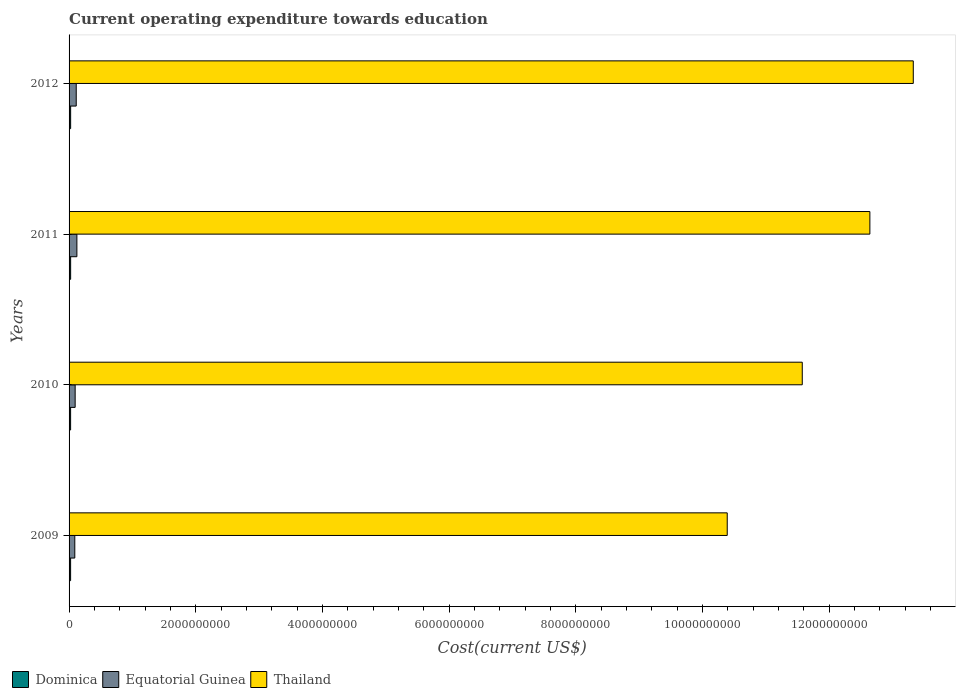How many groups of bars are there?
Your response must be concise. 4. Are the number of bars per tick equal to the number of legend labels?
Provide a short and direct response. Yes. Are the number of bars on each tick of the Y-axis equal?
Provide a succinct answer. Yes. How many bars are there on the 2nd tick from the bottom?
Your response must be concise. 3. What is the label of the 3rd group of bars from the top?
Provide a succinct answer. 2010. What is the expenditure towards education in Dominica in 2009?
Offer a very short reply. 2.43e+07. Across all years, what is the maximum expenditure towards education in Thailand?
Offer a very short reply. 1.33e+1. Across all years, what is the minimum expenditure towards education in Dominica?
Provide a short and direct response. 2.42e+07. What is the total expenditure towards education in Thailand in the graph?
Provide a short and direct response. 4.79e+1. What is the difference between the expenditure towards education in Equatorial Guinea in 2010 and that in 2012?
Provide a short and direct response. -1.69e+07. What is the difference between the expenditure towards education in Equatorial Guinea in 2009 and the expenditure towards education in Dominica in 2012?
Offer a very short reply. 6.57e+07. What is the average expenditure towards education in Thailand per year?
Give a very brief answer. 1.20e+1. In the year 2011, what is the difference between the expenditure towards education in Dominica and expenditure towards education in Equatorial Guinea?
Keep it short and to the point. -9.86e+07. In how many years, is the expenditure towards education in Dominica greater than 6800000000 US$?
Keep it short and to the point. 0. What is the ratio of the expenditure towards education in Thailand in 2011 to that in 2012?
Make the answer very short. 0.95. What is the difference between the highest and the second highest expenditure towards education in Dominica?
Offer a very short reply. 7.35e+04. What is the difference between the highest and the lowest expenditure towards education in Thailand?
Your response must be concise. 2.94e+09. Is the sum of the expenditure towards education in Equatorial Guinea in 2009 and 2011 greater than the maximum expenditure towards education in Dominica across all years?
Offer a very short reply. Yes. What does the 2nd bar from the top in 2011 represents?
Keep it short and to the point. Equatorial Guinea. What does the 1st bar from the bottom in 2010 represents?
Provide a succinct answer. Dominica. Is it the case that in every year, the sum of the expenditure towards education in Dominica and expenditure towards education in Equatorial Guinea is greater than the expenditure towards education in Thailand?
Your response must be concise. No. How many bars are there?
Provide a succinct answer. 12. Are all the bars in the graph horizontal?
Your response must be concise. Yes. Does the graph contain any zero values?
Provide a succinct answer. No. How many legend labels are there?
Give a very brief answer. 3. What is the title of the graph?
Your answer should be very brief. Current operating expenditure towards education. What is the label or title of the X-axis?
Provide a succinct answer. Cost(current US$). What is the label or title of the Y-axis?
Ensure brevity in your answer.  Years. What is the Cost(current US$) in Dominica in 2009?
Keep it short and to the point. 2.43e+07. What is the Cost(current US$) in Equatorial Guinea in 2009?
Provide a succinct answer. 9.05e+07. What is the Cost(current US$) of Thailand in 2009?
Offer a very short reply. 1.04e+1. What is the Cost(current US$) of Dominica in 2010?
Give a very brief answer. 2.42e+07. What is the Cost(current US$) in Equatorial Guinea in 2010?
Give a very brief answer. 9.61e+07. What is the Cost(current US$) of Thailand in 2010?
Provide a succinct answer. 1.16e+1. What is the Cost(current US$) in Dominica in 2011?
Provide a short and direct response. 2.49e+07. What is the Cost(current US$) in Equatorial Guinea in 2011?
Your response must be concise. 1.23e+08. What is the Cost(current US$) of Thailand in 2011?
Provide a short and direct response. 1.26e+1. What is the Cost(current US$) in Dominica in 2012?
Your answer should be compact. 2.48e+07. What is the Cost(current US$) of Equatorial Guinea in 2012?
Offer a terse response. 1.13e+08. What is the Cost(current US$) of Thailand in 2012?
Ensure brevity in your answer.  1.33e+1. Across all years, what is the maximum Cost(current US$) of Dominica?
Your answer should be compact. 2.49e+07. Across all years, what is the maximum Cost(current US$) in Equatorial Guinea?
Your answer should be compact. 1.23e+08. Across all years, what is the maximum Cost(current US$) in Thailand?
Give a very brief answer. 1.33e+1. Across all years, what is the minimum Cost(current US$) of Dominica?
Your response must be concise. 2.42e+07. Across all years, what is the minimum Cost(current US$) in Equatorial Guinea?
Give a very brief answer. 9.05e+07. Across all years, what is the minimum Cost(current US$) in Thailand?
Make the answer very short. 1.04e+1. What is the total Cost(current US$) in Dominica in the graph?
Offer a terse response. 9.82e+07. What is the total Cost(current US$) of Equatorial Guinea in the graph?
Offer a terse response. 4.23e+08. What is the total Cost(current US$) of Thailand in the graph?
Your answer should be very brief. 4.79e+1. What is the difference between the Cost(current US$) of Dominica in 2009 and that in 2010?
Your answer should be compact. 7.41e+04. What is the difference between the Cost(current US$) in Equatorial Guinea in 2009 and that in 2010?
Ensure brevity in your answer.  -5.64e+06. What is the difference between the Cost(current US$) in Thailand in 2009 and that in 2010?
Offer a terse response. -1.18e+09. What is the difference between the Cost(current US$) of Dominica in 2009 and that in 2011?
Your answer should be compact. -6.37e+05. What is the difference between the Cost(current US$) in Equatorial Guinea in 2009 and that in 2011?
Offer a terse response. -3.30e+07. What is the difference between the Cost(current US$) in Thailand in 2009 and that in 2011?
Provide a succinct answer. -2.25e+09. What is the difference between the Cost(current US$) of Dominica in 2009 and that in 2012?
Your answer should be very brief. -5.63e+05. What is the difference between the Cost(current US$) of Equatorial Guinea in 2009 and that in 2012?
Give a very brief answer. -2.26e+07. What is the difference between the Cost(current US$) of Thailand in 2009 and that in 2012?
Make the answer very short. -2.94e+09. What is the difference between the Cost(current US$) of Dominica in 2010 and that in 2011?
Your response must be concise. -7.11e+05. What is the difference between the Cost(current US$) in Equatorial Guinea in 2010 and that in 2011?
Your answer should be compact. -2.74e+07. What is the difference between the Cost(current US$) in Thailand in 2010 and that in 2011?
Make the answer very short. -1.07e+09. What is the difference between the Cost(current US$) of Dominica in 2010 and that in 2012?
Your answer should be compact. -6.37e+05. What is the difference between the Cost(current US$) of Equatorial Guinea in 2010 and that in 2012?
Give a very brief answer. -1.69e+07. What is the difference between the Cost(current US$) of Thailand in 2010 and that in 2012?
Make the answer very short. -1.75e+09. What is the difference between the Cost(current US$) in Dominica in 2011 and that in 2012?
Provide a succinct answer. 7.35e+04. What is the difference between the Cost(current US$) of Equatorial Guinea in 2011 and that in 2012?
Ensure brevity in your answer.  1.04e+07. What is the difference between the Cost(current US$) of Thailand in 2011 and that in 2012?
Your response must be concise. -6.85e+08. What is the difference between the Cost(current US$) in Dominica in 2009 and the Cost(current US$) in Equatorial Guinea in 2010?
Offer a terse response. -7.19e+07. What is the difference between the Cost(current US$) in Dominica in 2009 and the Cost(current US$) in Thailand in 2010?
Your answer should be very brief. -1.16e+1. What is the difference between the Cost(current US$) of Equatorial Guinea in 2009 and the Cost(current US$) of Thailand in 2010?
Keep it short and to the point. -1.15e+1. What is the difference between the Cost(current US$) in Dominica in 2009 and the Cost(current US$) in Equatorial Guinea in 2011?
Make the answer very short. -9.92e+07. What is the difference between the Cost(current US$) in Dominica in 2009 and the Cost(current US$) in Thailand in 2011?
Provide a succinct answer. -1.26e+1. What is the difference between the Cost(current US$) in Equatorial Guinea in 2009 and the Cost(current US$) in Thailand in 2011?
Provide a succinct answer. -1.26e+1. What is the difference between the Cost(current US$) in Dominica in 2009 and the Cost(current US$) in Equatorial Guinea in 2012?
Your answer should be compact. -8.88e+07. What is the difference between the Cost(current US$) in Dominica in 2009 and the Cost(current US$) in Thailand in 2012?
Your answer should be very brief. -1.33e+1. What is the difference between the Cost(current US$) in Equatorial Guinea in 2009 and the Cost(current US$) in Thailand in 2012?
Your answer should be very brief. -1.32e+1. What is the difference between the Cost(current US$) of Dominica in 2010 and the Cost(current US$) of Equatorial Guinea in 2011?
Your answer should be compact. -9.93e+07. What is the difference between the Cost(current US$) of Dominica in 2010 and the Cost(current US$) of Thailand in 2011?
Offer a very short reply. -1.26e+1. What is the difference between the Cost(current US$) of Equatorial Guinea in 2010 and the Cost(current US$) of Thailand in 2011?
Your answer should be very brief. -1.25e+1. What is the difference between the Cost(current US$) in Dominica in 2010 and the Cost(current US$) in Equatorial Guinea in 2012?
Offer a very short reply. -8.89e+07. What is the difference between the Cost(current US$) of Dominica in 2010 and the Cost(current US$) of Thailand in 2012?
Your answer should be compact. -1.33e+1. What is the difference between the Cost(current US$) in Equatorial Guinea in 2010 and the Cost(current US$) in Thailand in 2012?
Your response must be concise. -1.32e+1. What is the difference between the Cost(current US$) in Dominica in 2011 and the Cost(current US$) in Equatorial Guinea in 2012?
Make the answer very short. -8.82e+07. What is the difference between the Cost(current US$) of Dominica in 2011 and the Cost(current US$) of Thailand in 2012?
Offer a terse response. -1.33e+1. What is the difference between the Cost(current US$) of Equatorial Guinea in 2011 and the Cost(current US$) of Thailand in 2012?
Ensure brevity in your answer.  -1.32e+1. What is the average Cost(current US$) of Dominica per year?
Ensure brevity in your answer.  2.45e+07. What is the average Cost(current US$) in Equatorial Guinea per year?
Your answer should be compact. 1.06e+08. What is the average Cost(current US$) of Thailand per year?
Your answer should be very brief. 1.20e+1. In the year 2009, what is the difference between the Cost(current US$) in Dominica and Cost(current US$) in Equatorial Guinea?
Make the answer very short. -6.62e+07. In the year 2009, what is the difference between the Cost(current US$) of Dominica and Cost(current US$) of Thailand?
Give a very brief answer. -1.04e+1. In the year 2009, what is the difference between the Cost(current US$) of Equatorial Guinea and Cost(current US$) of Thailand?
Make the answer very short. -1.03e+1. In the year 2010, what is the difference between the Cost(current US$) in Dominica and Cost(current US$) in Equatorial Guinea?
Keep it short and to the point. -7.19e+07. In the year 2010, what is the difference between the Cost(current US$) in Dominica and Cost(current US$) in Thailand?
Provide a short and direct response. -1.16e+1. In the year 2010, what is the difference between the Cost(current US$) of Equatorial Guinea and Cost(current US$) of Thailand?
Provide a short and direct response. -1.15e+1. In the year 2011, what is the difference between the Cost(current US$) of Dominica and Cost(current US$) of Equatorial Guinea?
Your response must be concise. -9.86e+07. In the year 2011, what is the difference between the Cost(current US$) of Dominica and Cost(current US$) of Thailand?
Your answer should be compact. -1.26e+1. In the year 2011, what is the difference between the Cost(current US$) of Equatorial Guinea and Cost(current US$) of Thailand?
Give a very brief answer. -1.25e+1. In the year 2012, what is the difference between the Cost(current US$) of Dominica and Cost(current US$) of Equatorial Guinea?
Ensure brevity in your answer.  -8.82e+07. In the year 2012, what is the difference between the Cost(current US$) of Dominica and Cost(current US$) of Thailand?
Offer a very short reply. -1.33e+1. In the year 2012, what is the difference between the Cost(current US$) of Equatorial Guinea and Cost(current US$) of Thailand?
Provide a succinct answer. -1.32e+1. What is the ratio of the Cost(current US$) in Equatorial Guinea in 2009 to that in 2010?
Ensure brevity in your answer.  0.94. What is the ratio of the Cost(current US$) of Thailand in 2009 to that in 2010?
Offer a very short reply. 0.9. What is the ratio of the Cost(current US$) of Dominica in 2009 to that in 2011?
Your response must be concise. 0.97. What is the ratio of the Cost(current US$) of Equatorial Guinea in 2009 to that in 2011?
Your answer should be compact. 0.73. What is the ratio of the Cost(current US$) of Thailand in 2009 to that in 2011?
Your answer should be compact. 0.82. What is the ratio of the Cost(current US$) of Dominica in 2009 to that in 2012?
Provide a short and direct response. 0.98. What is the ratio of the Cost(current US$) of Equatorial Guinea in 2009 to that in 2012?
Give a very brief answer. 0.8. What is the ratio of the Cost(current US$) in Thailand in 2009 to that in 2012?
Provide a short and direct response. 0.78. What is the ratio of the Cost(current US$) of Dominica in 2010 to that in 2011?
Your response must be concise. 0.97. What is the ratio of the Cost(current US$) of Equatorial Guinea in 2010 to that in 2011?
Give a very brief answer. 0.78. What is the ratio of the Cost(current US$) of Thailand in 2010 to that in 2011?
Make the answer very short. 0.92. What is the ratio of the Cost(current US$) in Dominica in 2010 to that in 2012?
Offer a terse response. 0.97. What is the ratio of the Cost(current US$) in Equatorial Guinea in 2010 to that in 2012?
Ensure brevity in your answer.  0.85. What is the ratio of the Cost(current US$) of Thailand in 2010 to that in 2012?
Provide a succinct answer. 0.87. What is the ratio of the Cost(current US$) of Equatorial Guinea in 2011 to that in 2012?
Your answer should be compact. 1.09. What is the ratio of the Cost(current US$) in Thailand in 2011 to that in 2012?
Ensure brevity in your answer.  0.95. What is the difference between the highest and the second highest Cost(current US$) of Dominica?
Offer a very short reply. 7.35e+04. What is the difference between the highest and the second highest Cost(current US$) of Equatorial Guinea?
Give a very brief answer. 1.04e+07. What is the difference between the highest and the second highest Cost(current US$) of Thailand?
Provide a short and direct response. 6.85e+08. What is the difference between the highest and the lowest Cost(current US$) in Dominica?
Offer a terse response. 7.11e+05. What is the difference between the highest and the lowest Cost(current US$) of Equatorial Guinea?
Offer a very short reply. 3.30e+07. What is the difference between the highest and the lowest Cost(current US$) in Thailand?
Ensure brevity in your answer.  2.94e+09. 